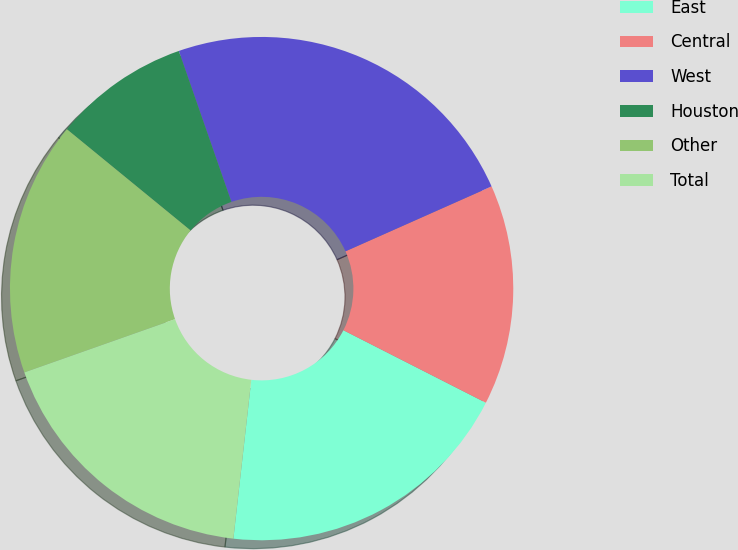Convert chart to OTSL. <chart><loc_0><loc_0><loc_500><loc_500><pie_chart><fcel>East<fcel>Central<fcel>West<fcel>Houston<fcel>Other<fcel>Total<nl><fcel>19.3%<fcel>14.15%<fcel>23.68%<fcel>8.75%<fcel>16.32%<fcel>17.81%<nl></chart> 